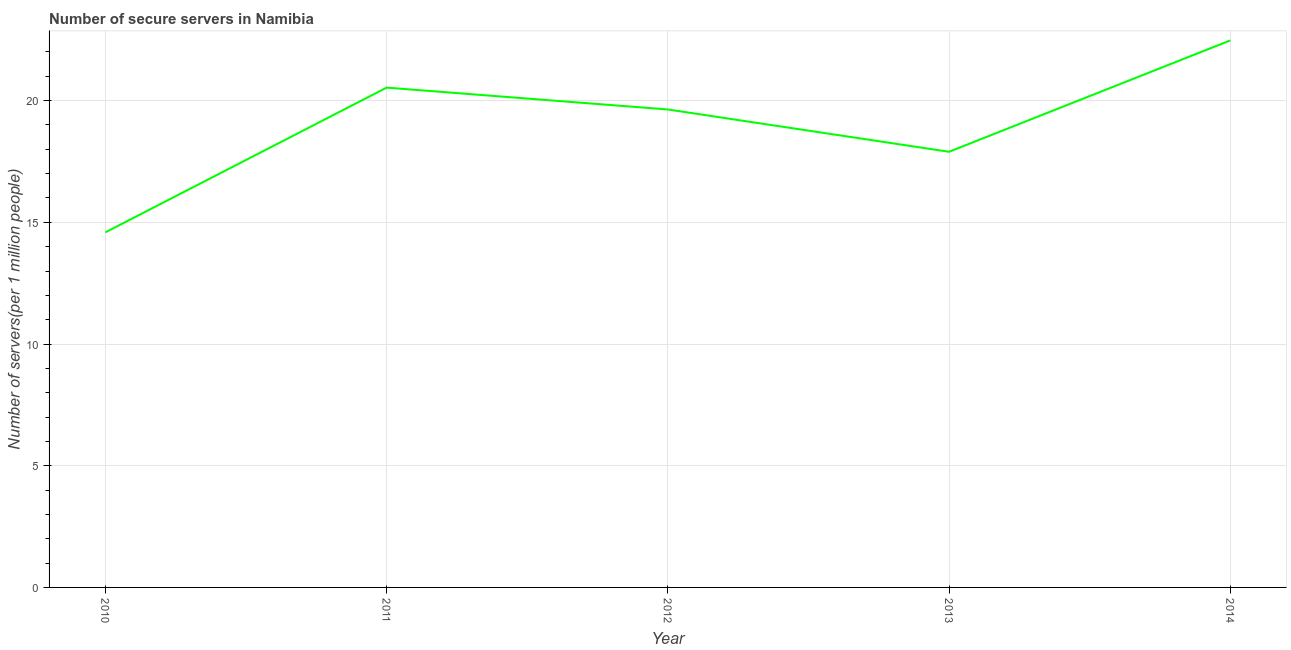What is the number of secure internet servers in 2010?
Give a very brief answer. 14.59. Across all years, what is the maximum number of secure internet servers?
Provide a succinct answer. 22.47. Across all years, what is the minimum number of secure internet servers?
Offer a very short reply. 14.59. What is the sum of the number of secure internet servers?
Give a very brief answer. 95.13. What is the difference between the number of secure internet servers in 2013 and 2014?
Offer a very short reply. -4.57. What is the average number of secure internet servers per year?
Your answer should be compact. 19.03. What is the median number of secure internet servers?
Make the answer very short. 19.64. Do a majority of the years between 2013 and 2011 (inclusive) have number of secure internet servers greater than 7 ?
Make the answer very short. No. What is the ratio of the number of secure internet servers in 2011 to that in 2012?
Your answer should be very brief. 1.05. What is the difference between the highest and the second highest number of secure internet servers?
Your response must be concise. 1.94. Is the sum of the number of secure internet servers in 2010 and 2012 greater than the maximum number of secure internet servers across all years?
Your response must be concise. Yes. What is the difference between the highest and the lowest number of secure internet servers?
Provide a succinct answer. 7.89. In how many years, is the number of secure internet servers greater than the average number of secure internet servers taken over all years?
Make the answer very short. 3. Does the number of secure internet servers monotonically increase over the years?
Give a very brief answer. No. Does the graph contain grids?
Offer a very short reply. Yes. What is the title of the graph?
Make the answer very short. Number of secure servers in Namibia. What is the label or title of the Y-axis?
Give a very brief answer. Number of servers(per 1 million people). What is the Number of servers(per 1 million people) in 2010?
Keep it short and to the point. 14.59. What is the Number of servers(per 1 million people) in 2011?
Offer a very short reply. 20.53. What is the Number of servers(per 1 million people) in 2012?
Your answer should be compact. 19.64. What is the Number of servers(per 1 million people) in 2013?
Your answer should be compact. 17.9. What is the Number of servers(per 1 million people) in 2014?
Your response must be concise. 22.47. What is the difference between the Number of servers(per 1 million people) in 2010 and 2011?
Keep it short and to the point. -5.95. What is the difference between the Number of servers(per 1 million people) in 2010 and 2012?
Give a very brief answer. -5.05. What is the difference between the Number of servers(per 1 million people) in 2010 and 2013?
Offer a terse response. -3.31. What is the difference between the Number of servers(per 1 million people) in 2010 and 2014?
Your answer should be compact. -7.89. What is the difference between the Number of servers(per 1 million people) in 2011 and 2012?
Offer a terse response. 0.9. What is the difference between the Number of servers(per 1 million people) in 2011 and 2013?
Provide a short and direct response. 2.64. What is the difference between the Number of servers(per 1 million people) in 2011 and 2014?
Offer a very short reply. -1.94. What is the difference between the Number of servers(per 1 million people) in 2012 and 2013?
Keep it short and to the point. 1.74. What is the difference between the Number of servers(per 1 million people) in 2012 and 2014?
Give a very brief answer. -2.84. What is the difference between the Number of servers(per 1 million people) in 2013 and 2014?
Provide a short and direct response. -4.57. What is the ratio of the Number of servers(per 1 million people) in 2010 to that in 2011?
Provide a short and direct response. 0.71. What is the ratio of the Number of servers(per 1 million people) in 2010 to that in 2012?
Make the answer very short. 0.74. What is the ratio of the Number of servers(per 1 million people) in 2010 to that in 2013?
Offer a very short reply. 0.81. What is the ratio of the Number of servers(per 1 million people) in 2010 to that in 2014?
Give a very brief answer. 0.65. What is the ratio of the Number of servers(per 1 million people) in 2011 to that in 2012?
Make the answer very short. 1.05. What is the ratio of the Number of servers(per 1 million people) in 2011 to that in 2013?
Offer a terse response. 1.15. What is the ratio of the Number of servers(per 1 million people) in 2011 to that in 2014?
Provide a short and direct response. 0.91. What is the ratio of the Number of servers(per 1 million people) in 2012 to that in 2013?
Keep it short and to the point. 1.1. What is the ratio of the Number of servers(per 1 million people) in 2012 to that in 2014?
Offer a terse response. 0.87. What is the ratio of the Number of servers(per 1 million people) in 2013 to that in 2014?
Ensure brevity in your answer.  0.8. 